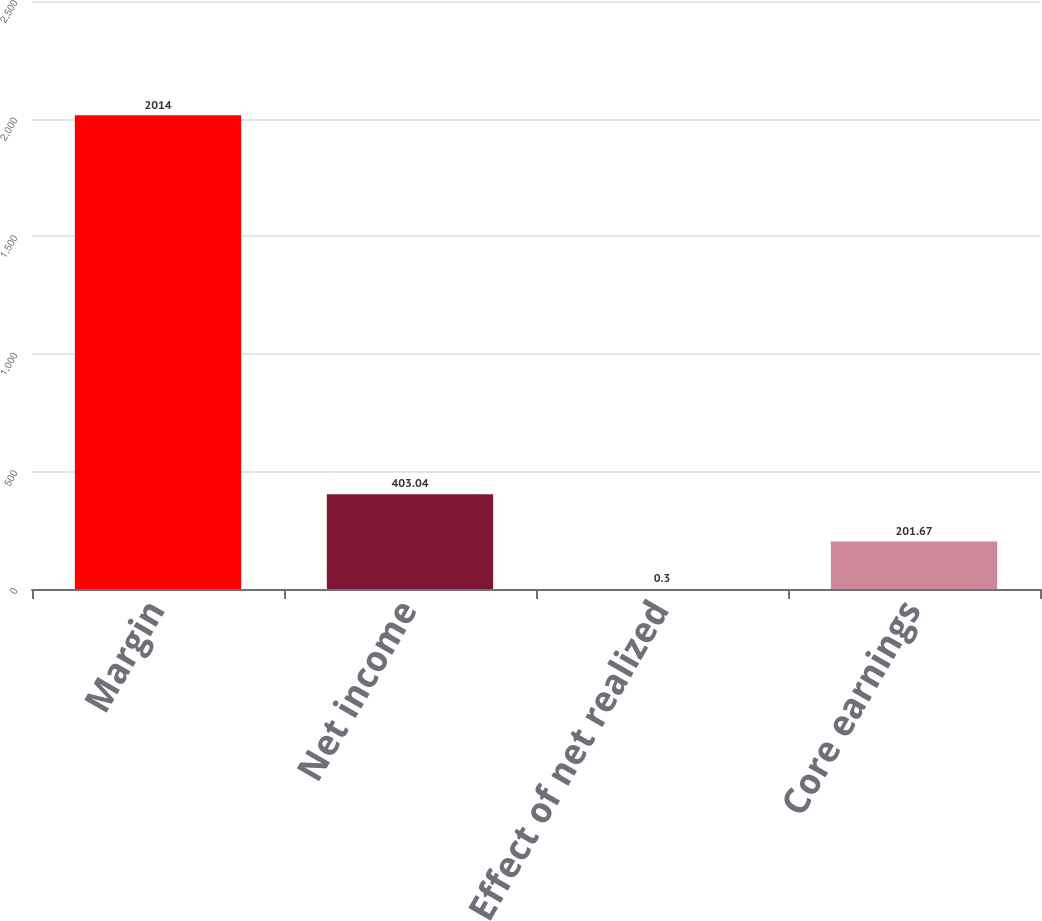Convert chart to OTSL. <chart><loc_0><loc_0><loc_500><loc_500><bar_chart><fcel>Margin<fcel>Net income<fcel>Effect of net realized<fcel>Core earnings<nl><fcel>2014<fcel>403.04<fcel>0.3<fcel>201.67<nl></chart> 